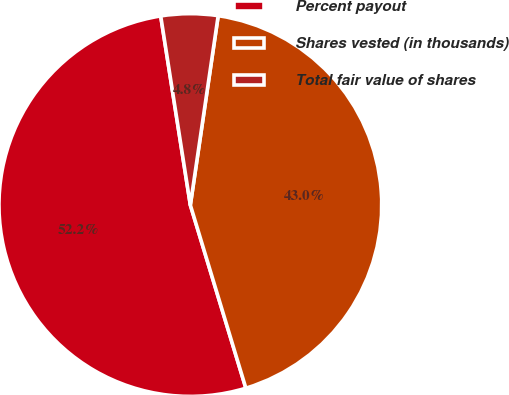Convert chart. <chart><loc_0><loc_0><loc_500><loc_500><pie_chart><fcel>Percent payout<fcel>Shares vested (in thousands)<fcel>Total fair value of shares<nl><fcel>52.21%<fcel>42.99%<fcel>4.8%<nl></chart> 